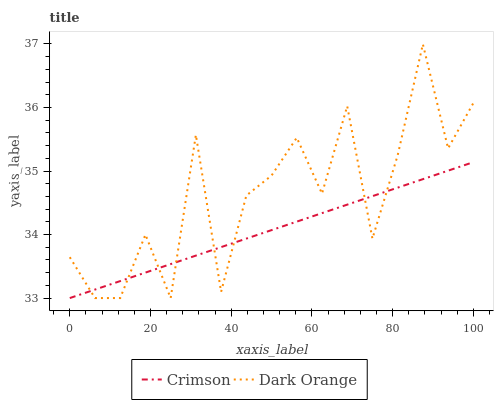Does Crimson have the minimum area under the curve?
Answer yes or no. Yes. Does Dark Orange have the maximum area under the curve?
Answer yes or no. Yes. Does Dark Orange have the minimum area under the curve?
Answer yes or no. No. Is Crimson the smoothest?
Answer yes or no. Yes. Is Dark Orange the roughest?
Answer yes or no. Yes. Is Dark Orange the smoothest?
Answer yes or no. No. Does Crimson have the lowest value?
Answer yes or no. Yes. Does Dark Orange have the highest value?
Answer yes or no. Yes. Does Dark Orange intersect Crimson?
Answer yes or no. Yes. Is Dark Orange less than Crimson?
Answer yes or no. No. Is Dark Orange greater than Crimson?
Answer yes or no. No. 